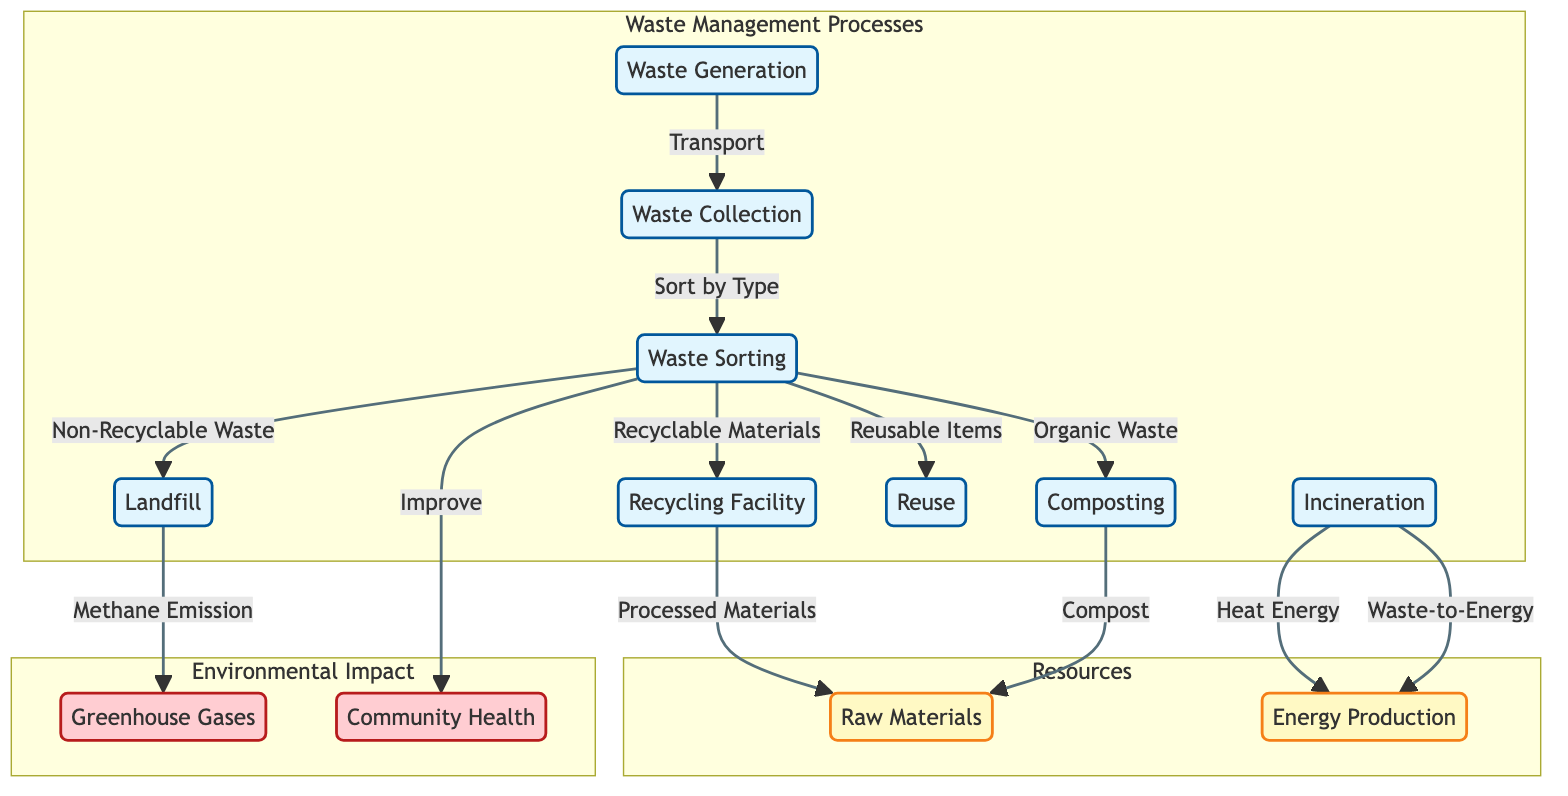What is the first process in the waste management flow? The first process in the waste management flow is labeled "Waste Generation". It is the starting point from which all subsequent processes stem.
Answer: Waste Generation How many waste management processes are shown in the diagram? The diagram displays a total of eight waste management processes, which are detailed nodes within the waste management subgraph.
Answer: 8 Which process is responsible for sorting waste by type? The process responsible for sorting waste by type is labeled "Waste Sorting". It takes inputs from both waste collection and leads to various outputs including recyclable and non-recyclable waste.
Answer: Waste Sorting What is produced from the recycling facility? The recycling facility produces "Processed Materials" as output, which transitions into the "Raw Materials" resource.
Answer: Processed Materials What environmental impact is linked to landfill processes? The landfill process is linked to "Methane Emission", which is categorized as a negative environmental impact. This shows an adverse effect linked directly to landfill practices.
Answer: Methane Emission How does incineration contribute to energy production? Incineration contributes to energy production through two main outputs: it generates "Heat Energy" and can be categorized under "Waste-to-Energy", illustrating the dual purpose of incineration in resource recovery.
Answer: Heat Energy Which process improves community health? The process that improves community health is "Waste Sorting", indicating that effective sorting can have positive effects on the surrounding community.
Answer: Waste Sorting What types of waste are sorted during the waste sorting process? During the waste sorting process, waste is sorted into four categories: "Recyclable Materials", "Non-Recyclable Waste", "Organic Waste", and "Reusable Items". This categorization identifies different pathways for waste management.
Answer: Recyclable Materials, Non-Recyclable Waste, Organic Waste, Reusable Items What is the relationship between composting and raw materials? The relationship is that composting produces “Compost”, an output that is transformed into "Raw Materials". This illustrates how organic waste is recycled back into useful products.
Answer: Compost 